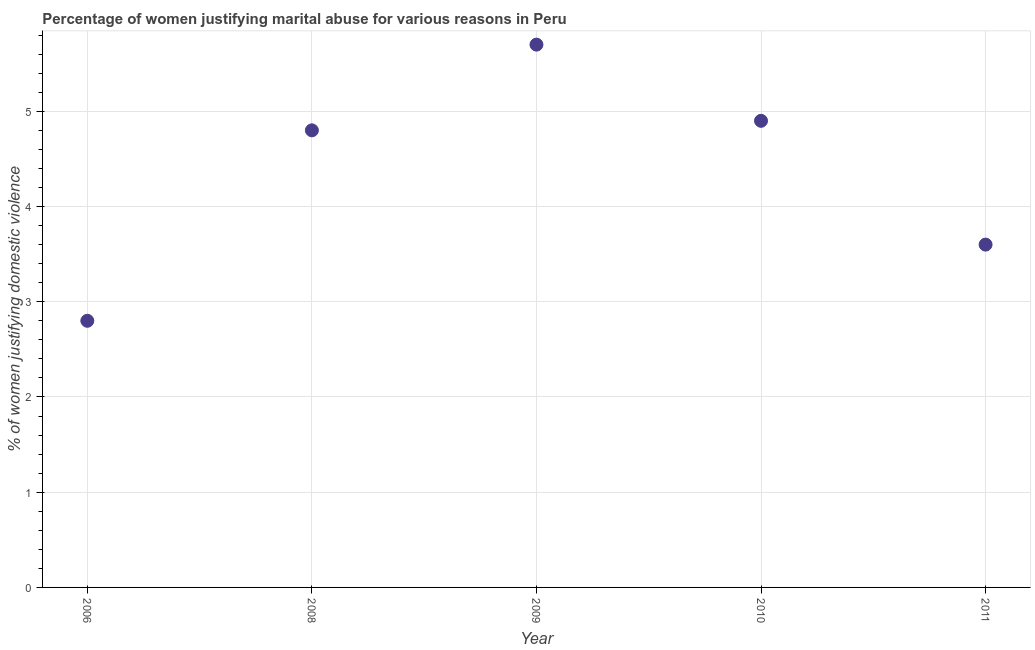Across all years, what is the minimum percentage of women justifying marital abuse?
Offer a very short reply. 2.8. What is the sum of the percentage of women justifying marital abuse?
Ensure brevity in your answer.  21.8. What is the difference between the percentage of women justifying marital abuse in 2006 and 2008?
Give a very brief answer. -2. What is the average percentage of women justifying marital abuse per year?
Keep it short and to the point. 4.36. What is the median percentage of women justifying marital abuse?
Offer a terse response. 4.8. What is the ratio of the percentage of women justifying marital abuse in 2006 to that in 2008?
Ensure brevity in your answer.  0.58. Is the difference between the percentage of women justifying marital abuse in 2008 and 2009 greater than the difference between any two years?
Your answer should be compact. No. What is the difference between the highest and the second highest percentage of women justifying marital abuse?
Your response must be concise. 0.8. What is the difference between the highest and the lowest percentage of women justifying marital abuse?
Keep it short and to the point. 2.9. Does the percentage of women justifying marital abuse monotonically increase over the years?
Provide a short and direct response. No. How many dotlines are there?
Offer a terse response. 1. How many years are there in the graph?
Provide a short and direct response. 5. Are the values on the major ticks of Y-axis written in scientific E-notation?
Offer a very short reply. No. Does the graph contain any zero values?
Make the answer very short. No. What is the title of the graph?
Your answer should be very brief. Percentage of women justifying marital abuse for various reasons in Peru. What is the label or title of the X-axis?
Offer a terse response. Year. What is the label or title of the Y-axis?
Your answer should be very brief. % of women justifying domestic violence. What is the % of women justifying domestic violence in 2006?
Your response must be concise. 2.8. What is the % of women justifying domestic violence in 2009?
Offer a terse response. 5.7. What is the % of women justifying domestic violence in 2011?
Ensure brevity in your answer.  3.6. What is the difference between the % of women justifying domestic violence in 2008 and 2009?
Provide a succinct answer. -0.9. What is the difference between the % of women justifying domestic violence in 2009 and 2010?
Provide a succinct answer. 0.8. What is the difference between the % of women justifying domestic violence in 2009 and 2011?
Provide a succinct answer. 2.1. What is the ratio of the % of women justifying domestic violence in 2006 to that in 2008?
Provide a succinct answer. 0.58. What is the ratio of the % of women justifying domestic violence in 2006 to that in 2009?
Provide a short and direct response. 0.49. What is the ratio of the % of women justifying domestic violence in 2006 to that in 2010?
Provide a short and direct response. 0.57. What is the ratio of the % of women justifying domestic violence in 2006 to that in 2011?
Provide a succinct answer. 0.78. What is the ratio of the % of women justifying domestic violence in 2008 to that in 2009?
Provide a succinct answer. 0.84. What is the ratio of the % of women justifying domestic violence in 2008 to that in 2011?
Provide a short and direct response. 1.33. What is the ratio of the % of women justifying domestic violence in 2009 to that in 2010?
Your response must be concise. 1.16. What is the ratio of the % of women justifying domestic violence in 2009 to that in 2011?
Make the answer very short. 1.58. What is the ratio of the % of women justifying domestic violence in 2010 to that in 2011?
Provide a succinct answer. 1.36. 